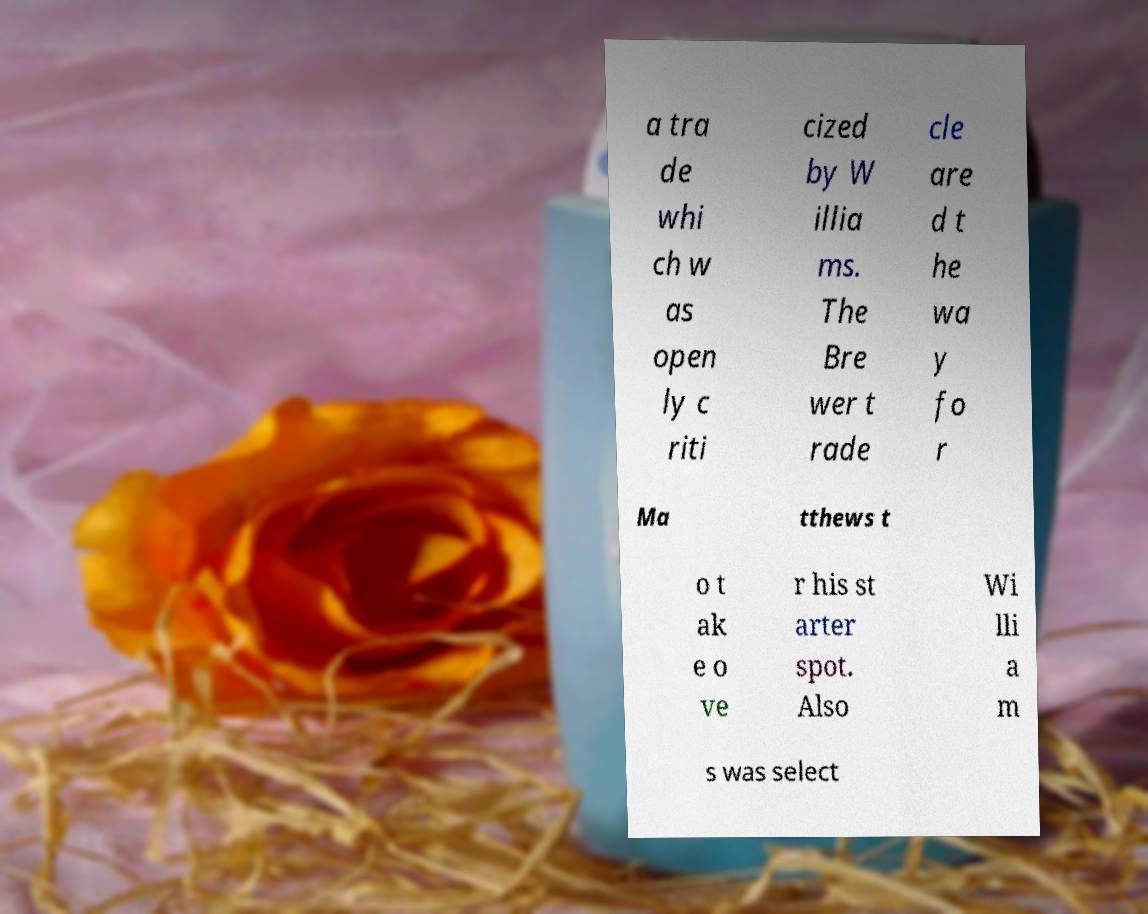I need the written content from this picture converted into text. Can you do that? a tra de whi ch w as open ly c riti cized by W illia ms. The Bre wer t rade cle are d t he wa y fo r Ma tthews t o t ak e o ve r his st arter spot. Also Wi lli a m s was select 